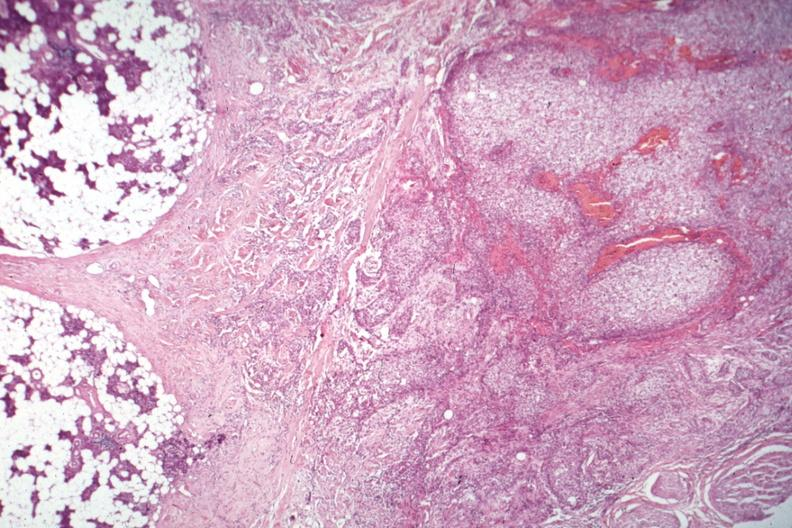what does this image show?
Answer the question using a single word or phrase. Nice photo of parotid on one side with tumor capsule and obvious invasive tumor 